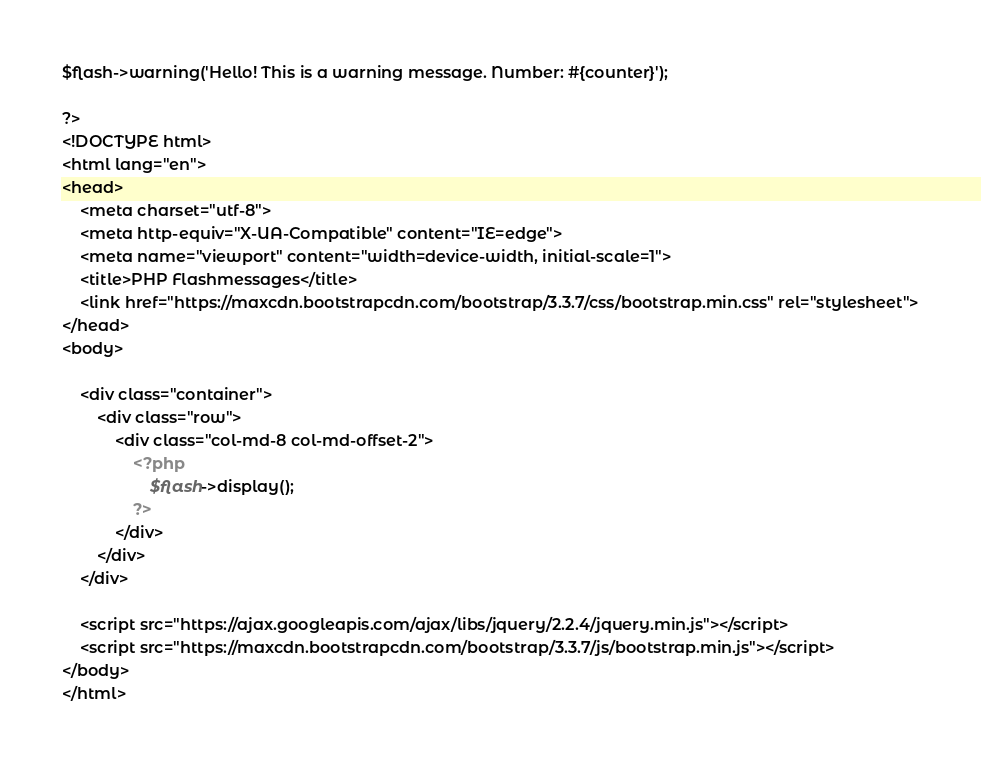<code> <loc_0><loc_0><loc_500><loc_500><_PHP_>$flash->warning('Hello! This is a warning message. Number: #{counter}');

?>
<!DOCTYPE html>
<html lang="en">
<head>
    <meta charset="utf-8">
    <meta http-equiv="X-UA-Compatible" content="IE=edge">
    <meta name="viewport" content="width=device-width, initial-scale=1">
    <title>PHP Flashmessages</title>
    <link href="https://maxcdn.bootstrapcdn.com/bootstrap/3.3.7/css/bootstrap.min.css" rel="stylesheet">
</head>
<body>

    <div class="container">
        <div class="row">
            <div class="col-md-8 col-md-offset-2">
                <?php
                    $flash->display();
                ?>
            </div>
        </div>
    </div>

    <script src="https://ajax.googleapis.com/ajax/libs/jquery/2.2.4/jquery.min.js"></script>
    <script src="https://maxcdn.bootstrapcdn.com/bootstrap/3.3.7/js/bootstrap.min.js"></script>
</body>
</html></code> 